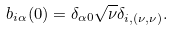<formula> <loc_0><loc_0><loc_500><loc_500>b _ { i \alpha } ( 0 ) = \delta _ { \alpha 0 } \sqrt { \nu } \delta _ { i , ( \nu , \nu ) } .</formula> 